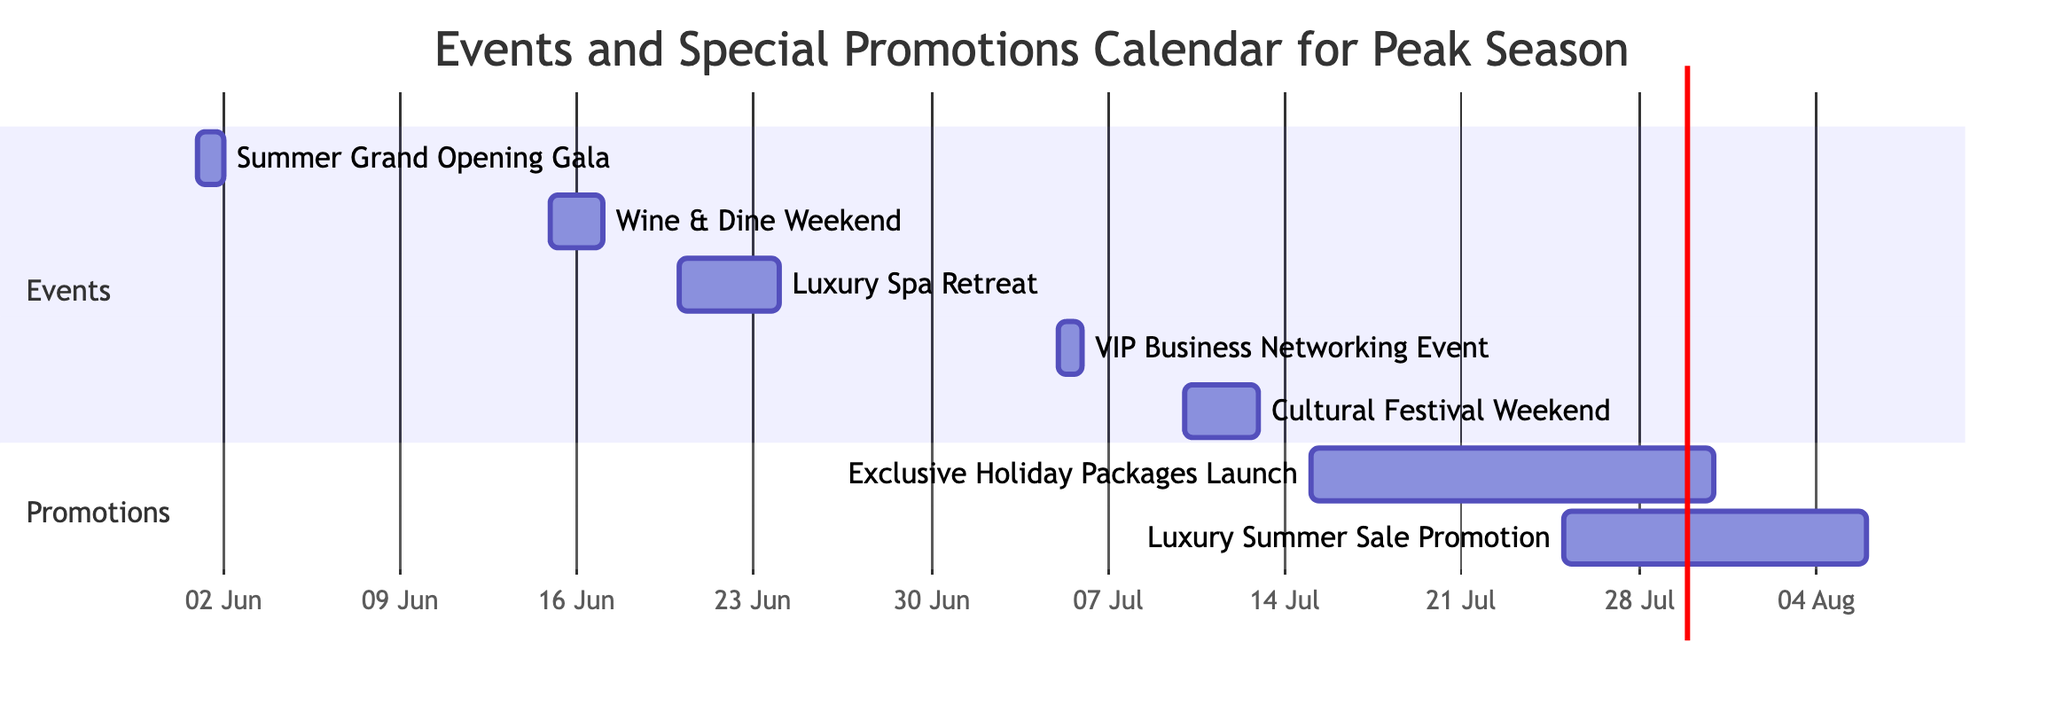What is the duration of the Luxury Spa Retreat? The Luxury Spa Retreat event starts on June 20, 2024, and ends on June 23, 2024. Counting the number of days from start to end gives a total of 4 days.
Answer: 4 days Which event takes place on July 5, 2024? The event scheduled for July 5, 2024, is the VIP Business Networking Event. It is marked on the Gantt chart with a specific date and duration of 1 day.
Answer: VIP Business Networking Event How many events are shown in the diagram? The diagram lists a total of 6 events, including both events and promotions, as counted from the Events section.
Answer: 6 Which two events occur back-to-back in mid-July? The two events occurring in mid-July are the Cultural Festival Weekend, which ends on July 12, and the Exclusive Holiday Packages Launch, which begins on July 15. Since these events are consecutive, they occur back-to-back.
Answer: Cultural Festival Weekend and Exclusive Holiday Packages Launch What is the total duration of the Luxury Summer Sale Promotion? The Luxury Summer Sale Promotion starts on July 25, 2024, and extends to August 5, 2024. The duration, therefore, spans 12 days.
Answer: 12 days Which event has the longest duration? The event with the longest duration is the Exclusive Holiday Packages Launch, which lasts for 16 days, starting on July 15 and ending on July 30.
Answer: Exclusive Holiday Packages Launch During which section of the Gantt chart is the Luxury Spa Retreat found? The Luxury Spa Retreat is found in the Events section of the Gantt chart, specifically under the 'Events' label.
Answer: Events When does the Summer Grand Opening Gala happen? The Summer Grand Opening Gala occurs on June 1, 2024, as indicated by the start date of this specific event entry in the Gantt chart.
Answer: June 1, 2024 What is the relationship between the Wine & Dine Weekend and the Luxury Spa Retreat in terms of event timing? The Wine & Dine Weekend takes place first, from June 15 to June 16, followed by the Luxury Spa Retreat, which starts on June 20. This shows that the Wine & Dine Weekend precedes the Luxury Spa Retreat.
Answer: Wine & Dine Weekend precedes Luxury Spa Retreat 